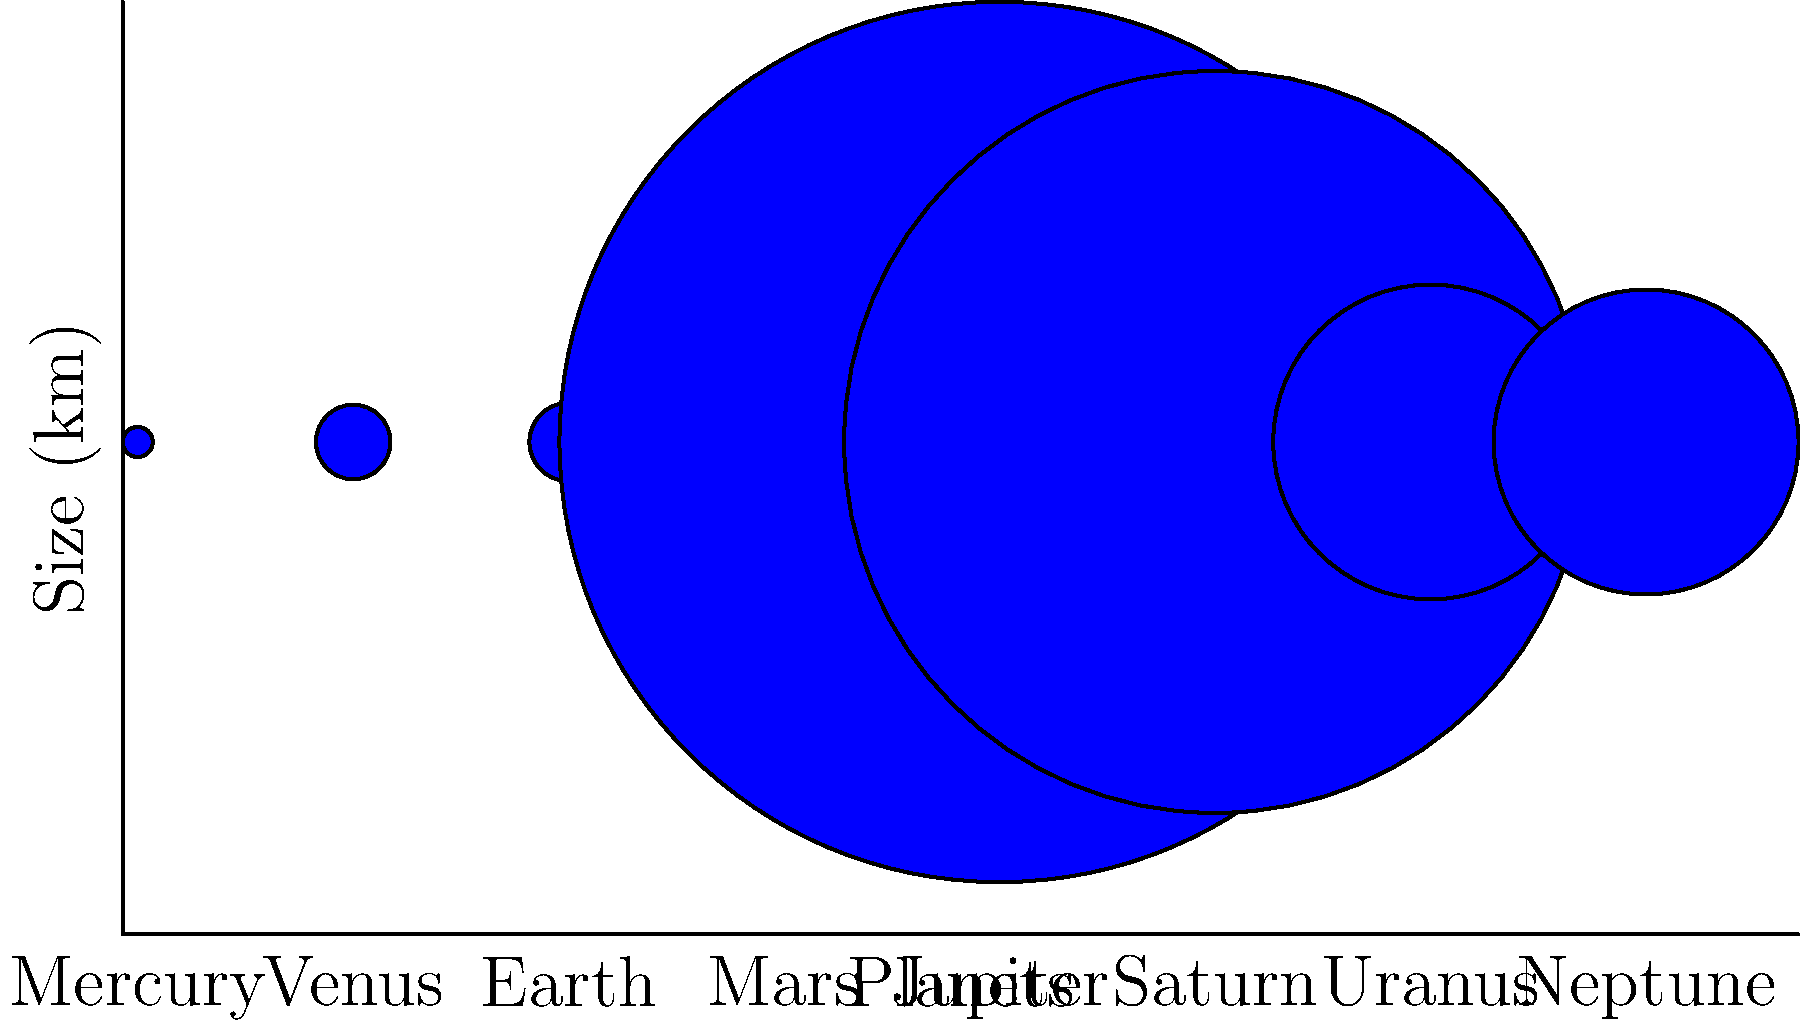As a medical intern in Dhaka, you're discussing the vastness of space with a patient to help ease their anxiety. Looking at the diagram showing the relative sizes of planets in our solar system, which planet is significantly larger than the others, and approximately how many times larger is it than Earth? Let's approach this step-by-step:

1. Observe the diagram: The planets are represented by circles, with their sizes proportional to their actual diameters.

2. Identify the largest planet: Jupiter is clearly much larger than the other planets.

3. Compare Jupiter to Earth:
   - Jupiter's diameter: 142,984 km
   - Earth's diameter: 12,756 km

4. Calculate the ratio:
   $$ \text{Ratio} = \frac{\text{Jupiter's diameter}}{\text{Earth's diameter}} = \frac{142,984}{12,756} \approx 11.21 $$

5. Round to the nearest whole number:
   11.21 rounds to 11

Therefore, Jupiter is approximately 11 times larger than Earth in diameter.
Answer: Jupiter, approximately 11 times larger than Earth 